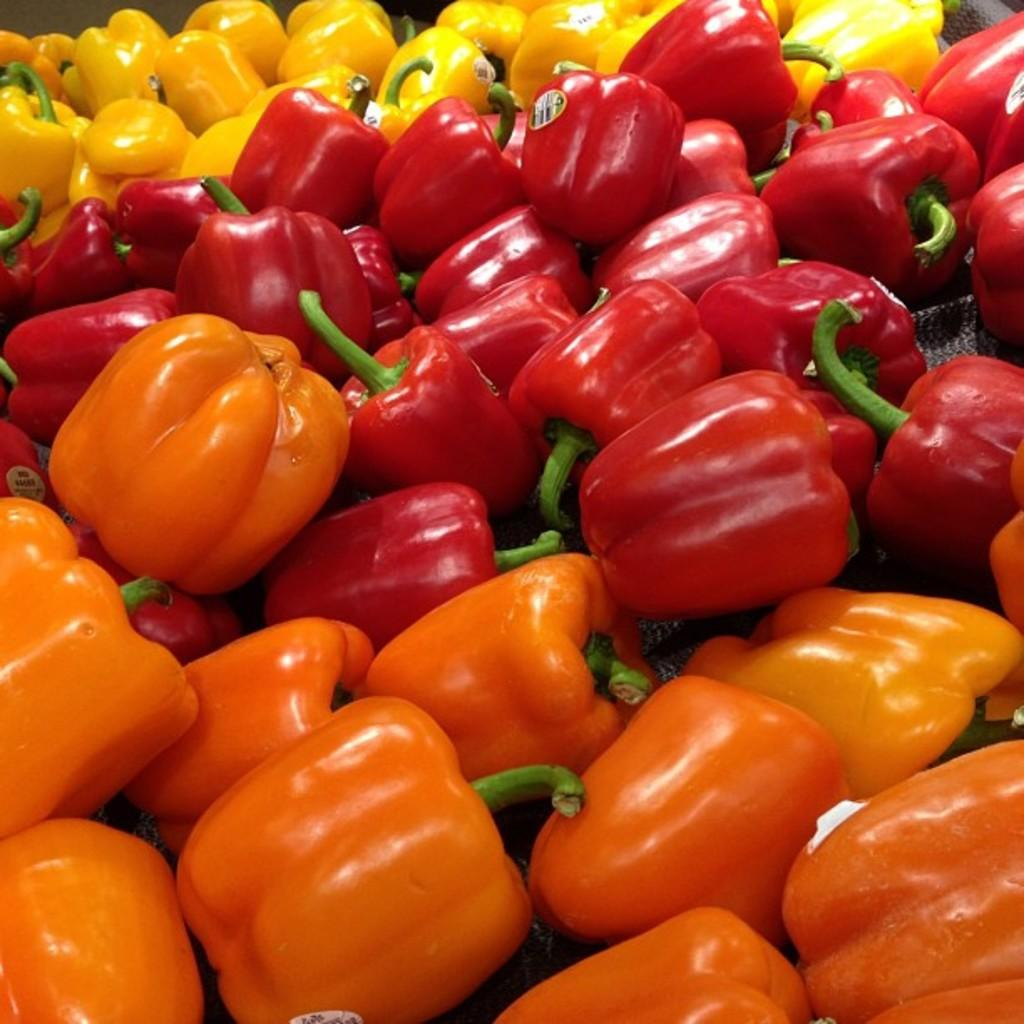What type of vegetables are in the image? There are capsicums in the image. What colors can be seen among the capsicums? The capsicums are yellow, red, green, and orange in color. Are there any additional features on some of the capsicums? Yes, there are stickers attached to some of the capsicums. What type of curtain is hanging in front of the capsicums in the image? There is no curtain present in the image; it features capsicums with stickers. What force is being applied to the capsicums in the image? There is no force being applied to the capsicums in the image; they are stationary. 